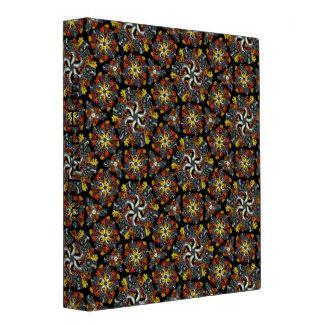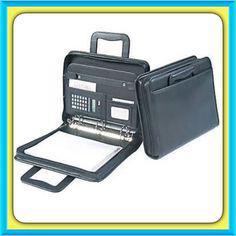The first image is the image on the left, the second image is the image on the right. Analyze the images presented: Is the assertion "There are writing utensils inside a mesh compartment." valid? Answer yes or no. No. 